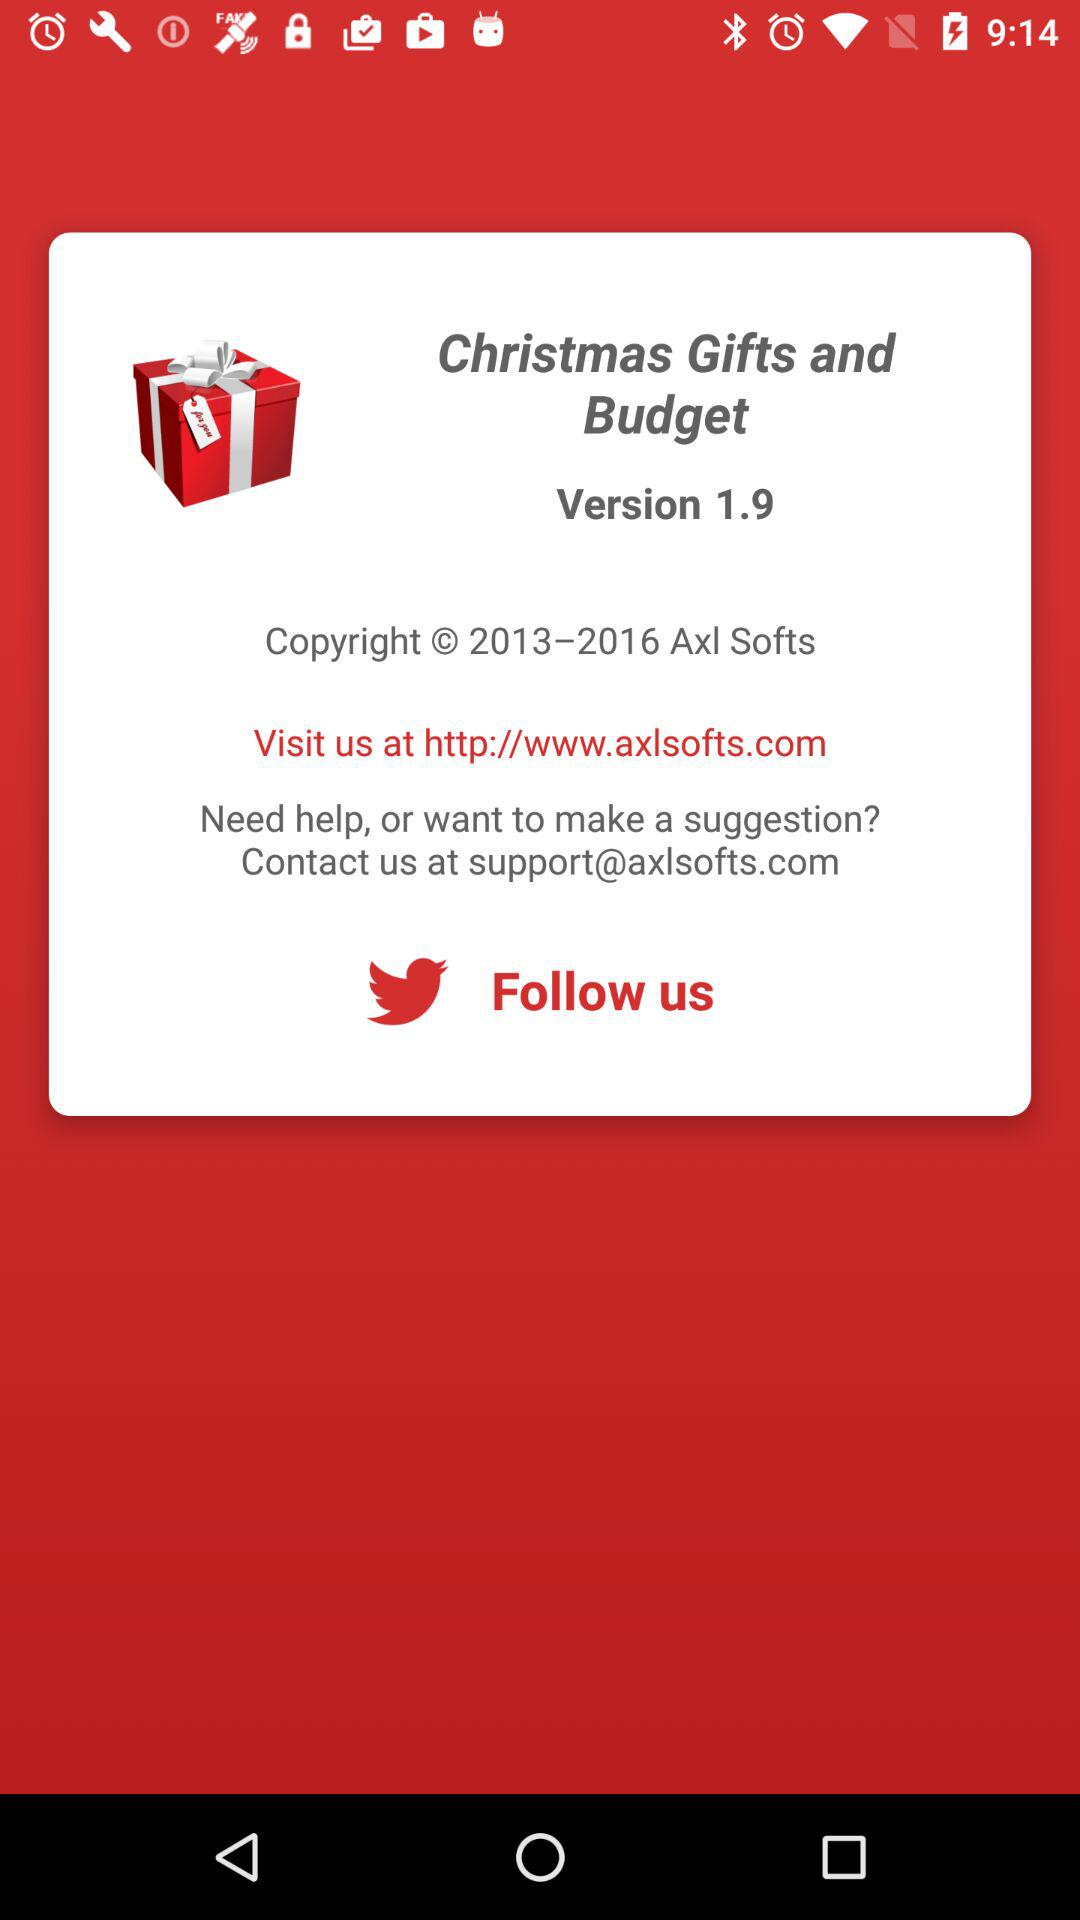What is the email address to contact? The email address to contact is support@axlsofts.com. 